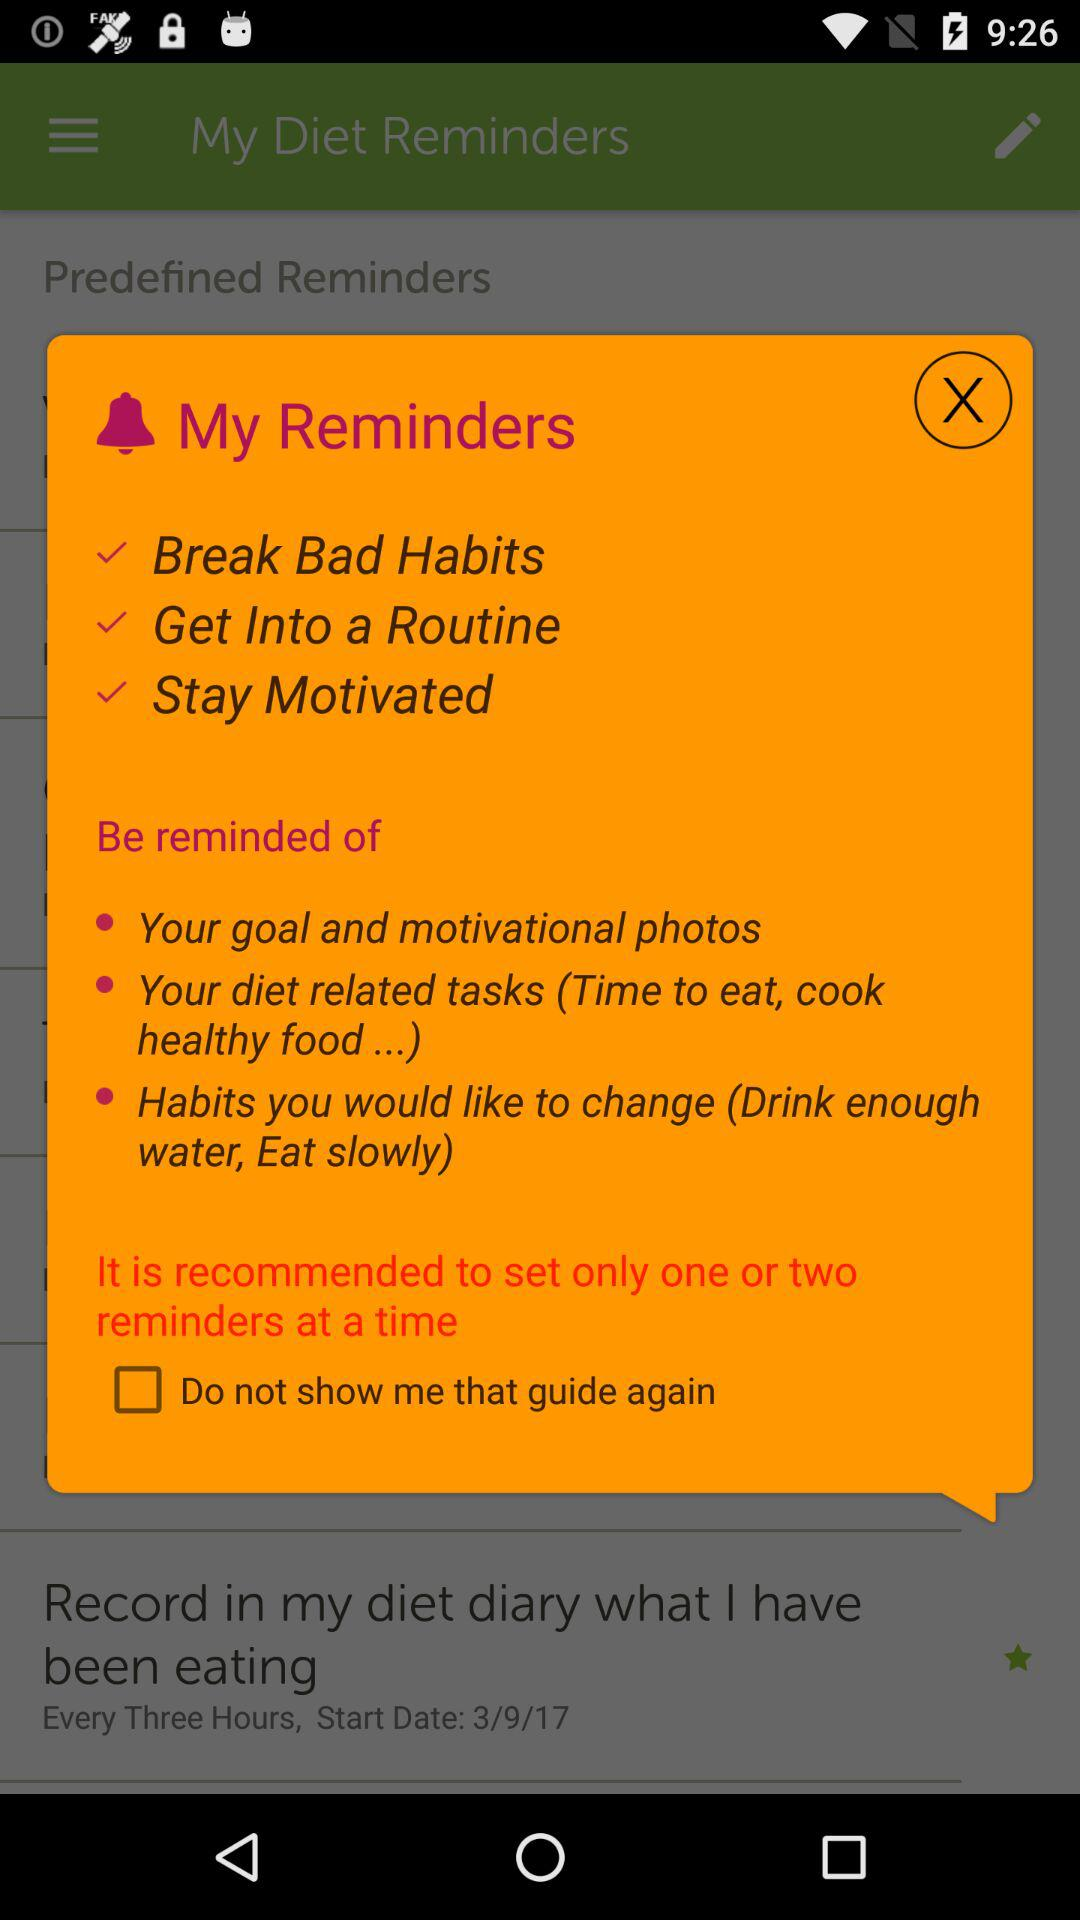How many reminders are there?
Answer the question using a single word or phrase. 3 